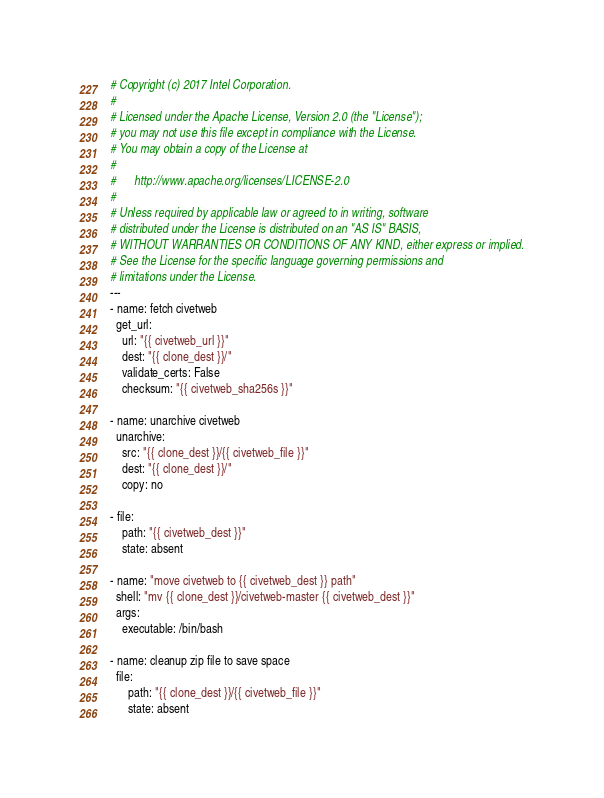<code> <loc_0><loc_0><loc_500><loc_500><_YAML_># Copyright (c) 2017 Intel Corporation.
#
# Licensed under the Apache License, Version 2.0 (the "License");
# you may not use this file except in compliance with the License.
# You may obtain a copy of the License at
#
#      http://www.apache.org/licenses/LICENSE-2.0
#
# Unless required by applicable law or agreed to in writing, software
# distributed under the License is distributed on an "AS IS" BASIS,
# WITHOUT WARRANTIES OR CONDITIONS OF ANY KIND, either express or implied.
# See the License for the specific language governing permissions and
# limitations under the License.
---
- name: fetch civetweb
  get_url:
    url: "{{ civetweb_url }}"
    dest: "{{ clone_dest }}/"
    validate_certs: False
    checksum: "{{ civetweb_sha256s }}"

- name: unarchive civetweb
  unarchive:
    src: "{{ clone_dest }}/{{ civetweb_file }}"
    dest: "{{ clone_dest }}/"
    copy: no

- file:
    path: "{{ civetweb_dest }}"
    state: absent

- name: "move civetweb to {{ civetweb_dest }} path"
  shell: "mv {{ clone_dest }}/civetweb-master {{ civetweb_dest }}"
  args:
    executable: /bin/bash

- name: cleanup zip file to save space
  file:
      path: "{{ clone_dest }}/{{ civetweb_file }}"
      state: absent
</code> 